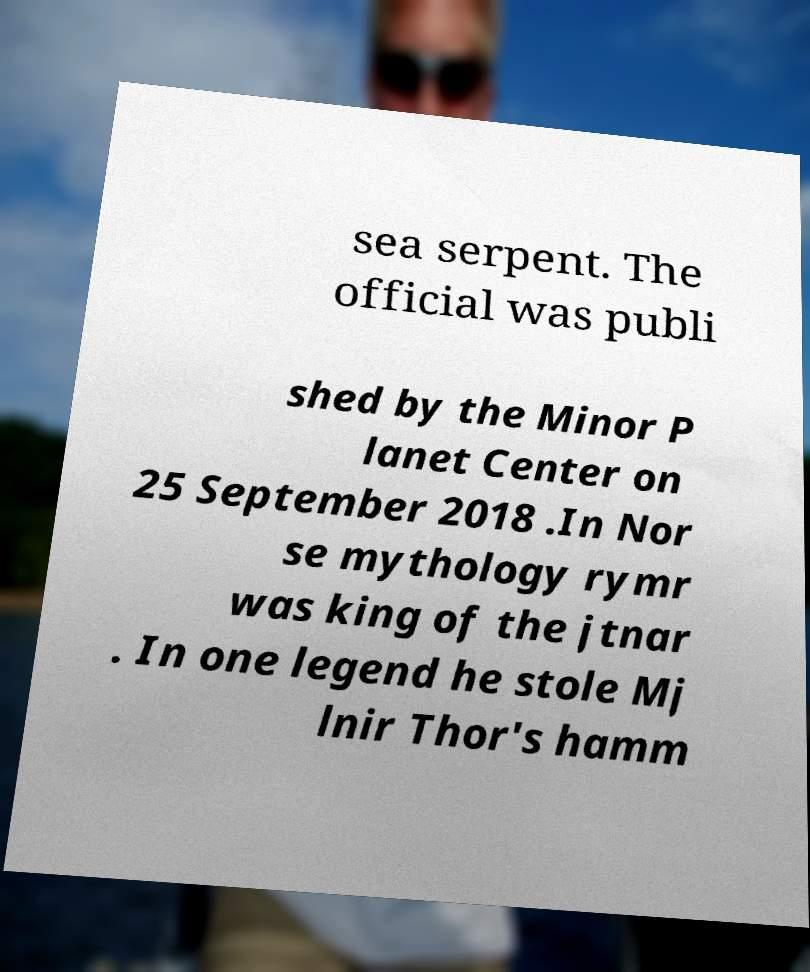Please identify and transcribe the text found in this image. sea serpent. The official was publi shed by the Minor P lanet Center on 25 September 2018 .In Nor se mythology rymr was king of the jtnar . In one legend he stole Mj lnir Thor's hamm 